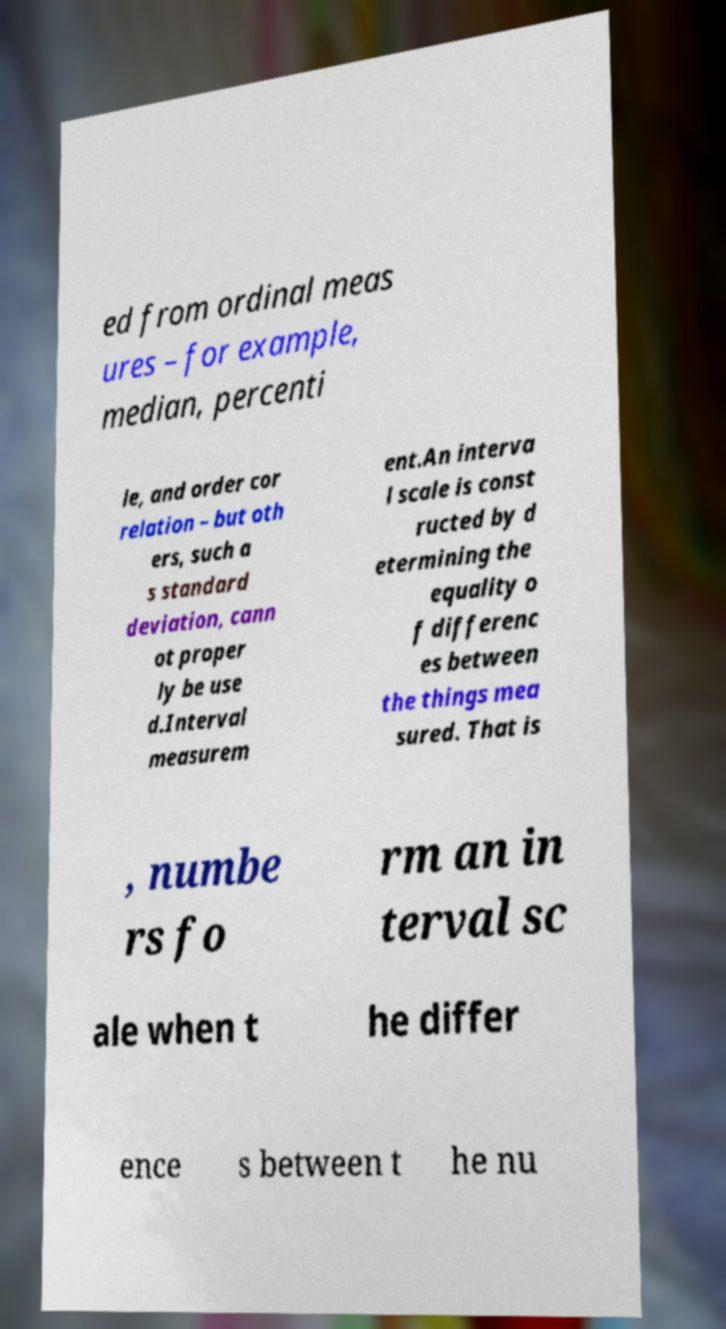Please read and relay the text visible in this image. What does it say? ed from ordinal meas ures – for example, median, percenti le, and order cor relation – but oth ers, such a s standard deviation, cann ot proper ly be use d.Interval measurem ent.An interva l scale is const ructed by d etermining the equality o f differenc es between the things mea sured. That is , numbe rs fo rm an in terval sc ale when t he differ ence s between t he nu 